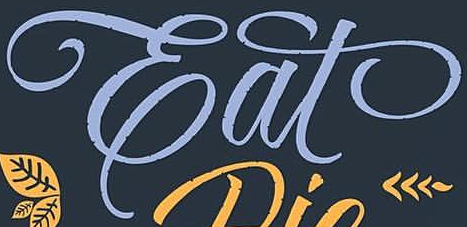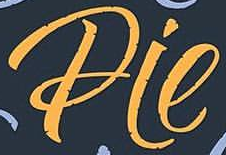What text appears in these images from left to right, separated by a semicolon? Eat; Pie 